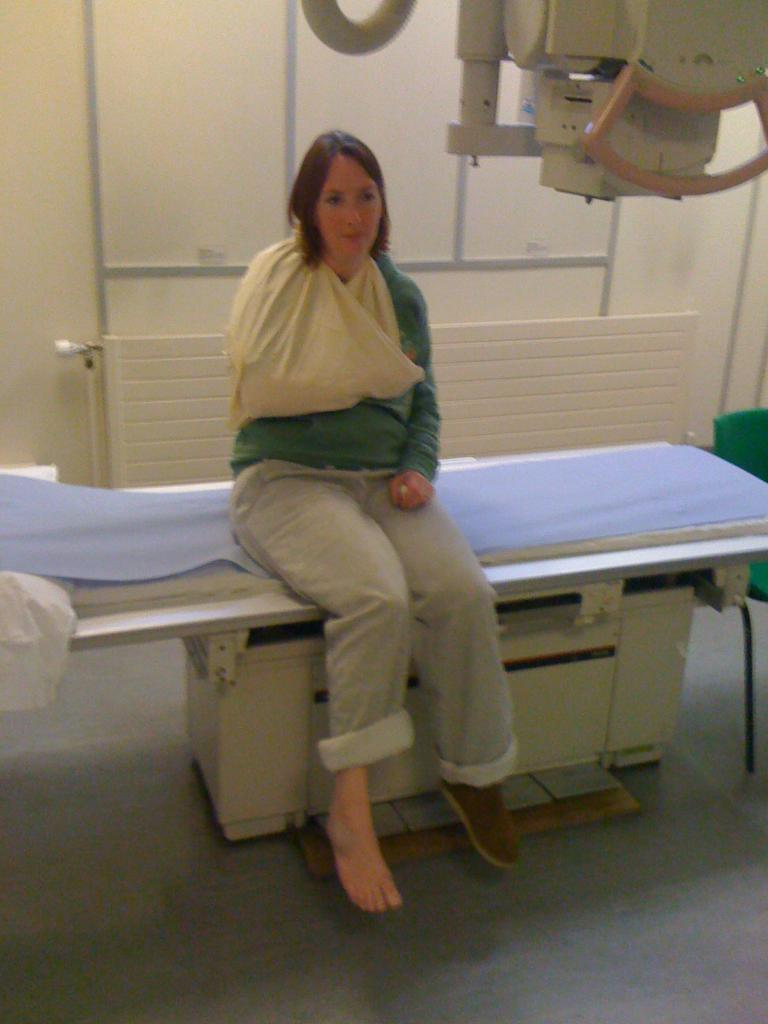What is the woman doing in the foreground of the image? The woman is sitting on a bed in the foreground. What can be seen in the background of the image? There is a wall, a bench, a chair, and a machine in the background. What type of setting is suggested by the presence of these objects? The image is likely taken in a room, given the presence of a bed and various pieces of furniture. What type of animal can be seen drawing on the wall with chalk in the image? There is no animal present in the image, nor is there any chalk or drawing on the wall. 